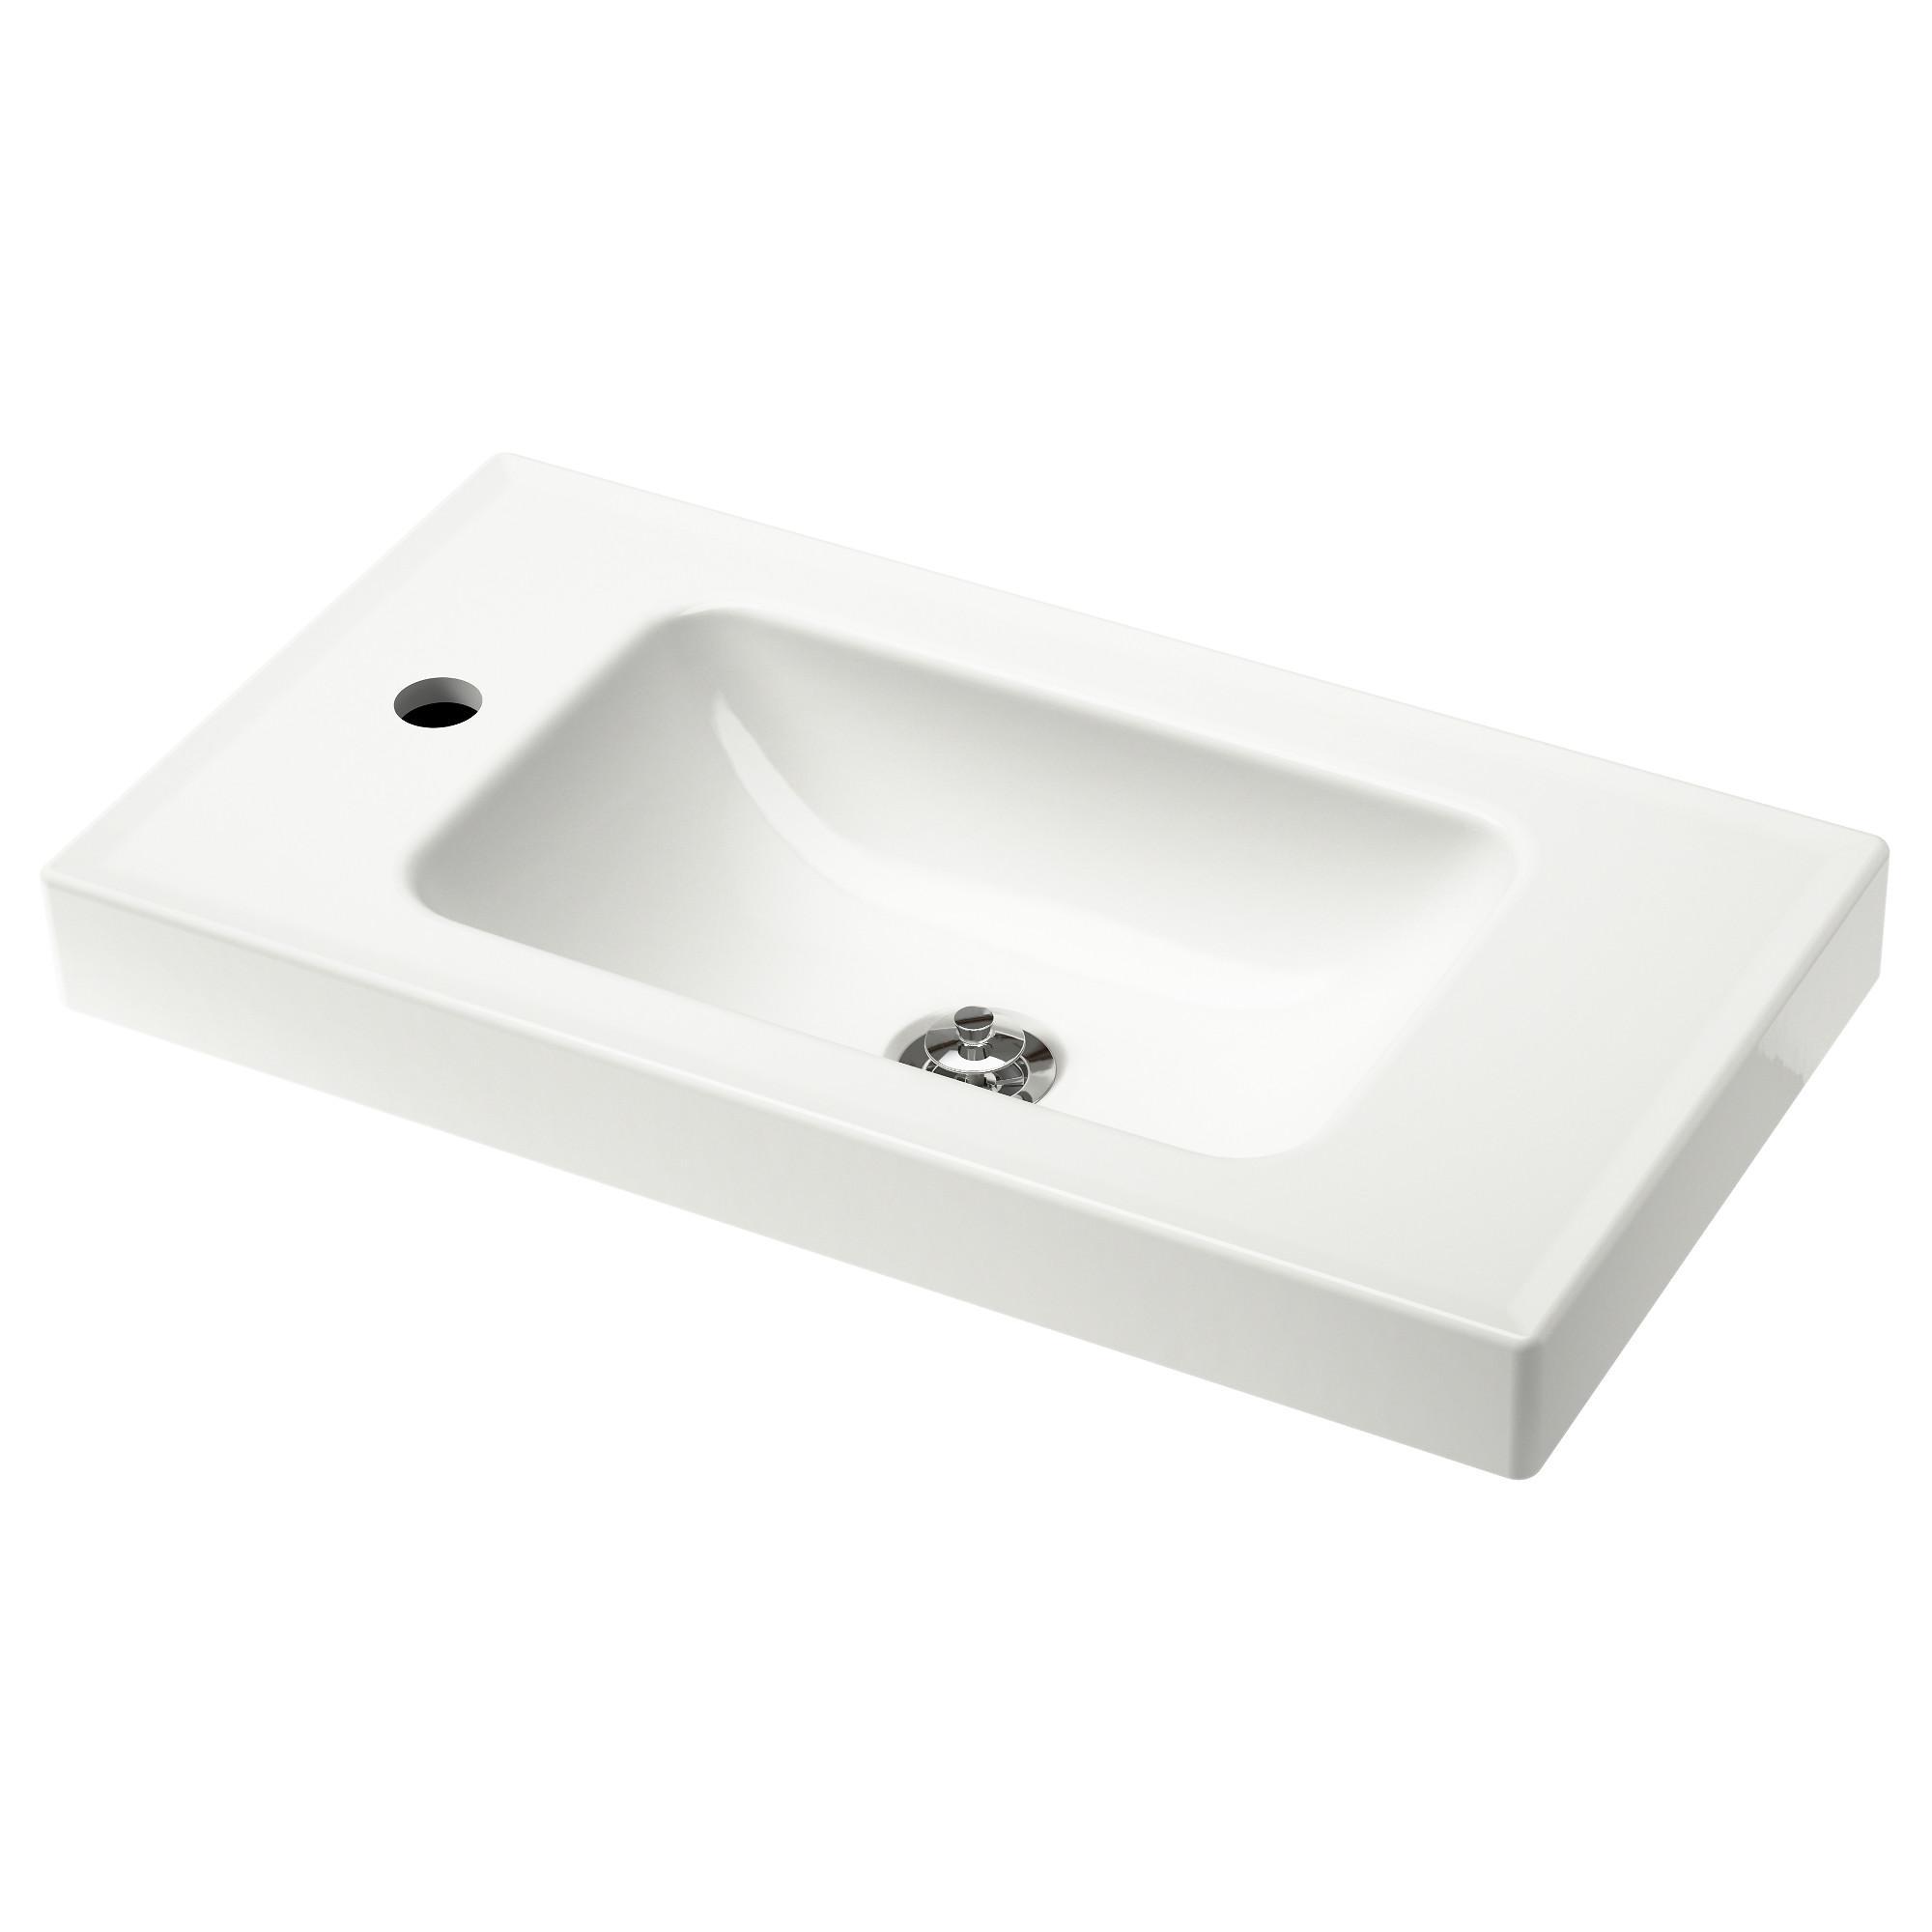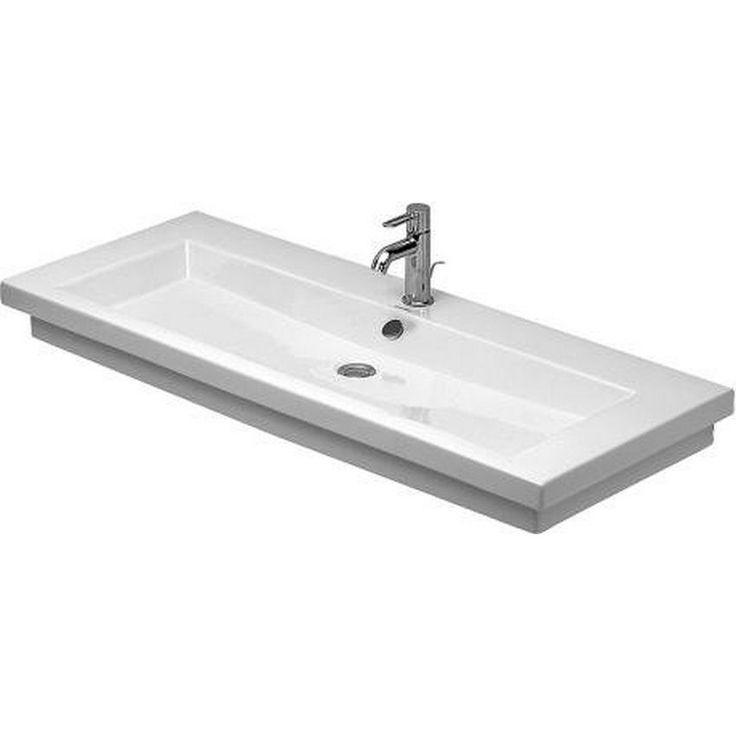The first image is the image on the left, the second image is the image on the right. Given the left and right images, does the statement "The basin in the image on the left is set into a counter." hold true? Answer yes or no. No. The first image is the image on the left, the second image is the image on the right. Evaluate the accuracy of this statement regarding the images: "One sink has a white rectangular recessed bowl and no faucet or spout mounted to it.". Is it true? Answer yes or no. Yes. 